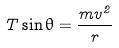<formula> <loc_0><loc_0><loc_500><loc_500>T \sin \theta = \frac { m v ^ { 2 } } { r }</formula> 